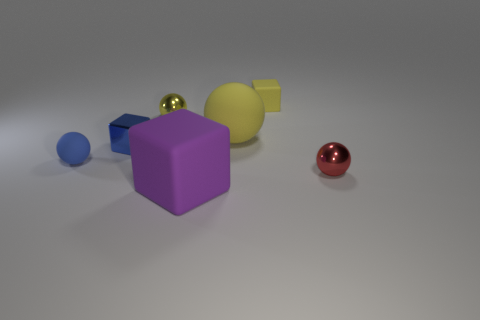What is the color of the tiny block to the right of the big rubber thing that is right of the big purple matte cube?
Give a very brief answer. Yellow. What number of tiny things are red things or rubber things?
Keep it short and to the point. 3. How many big yellow objects have the same material as the yellow cube?
Ensure brevity in your answer.  1. There is a matte ball in front of the shiny cube; how big is it?
Your answer should be very brief. Small. The small rubber object left of the rubber block in front of the blue rubber object is what shape?
Keep it short and to the point. Sphere. There is a matte block that is in front of the metallic ball in front of the blue block; what number of spheres are on the left side of it?
Provide a short and direct response. 2. Are there fewer small red things that are in front of the large purple thing than purple rubber objects?
Give a very brief answer. Yes. Is there anything else that is the same shape as the red metal thing?
Offer a very short reply. Yes. The small rubber object in front of the large yellow rubber sphere has what shape?
Offer a very short reply. Sphere. There is a tiny rubber thing on the right side of the big yellow ball that is in front of the tiny rubber object that is on the right side of the big purple block; what shape is it?
Ensure brevity in your answer.  Cube. 